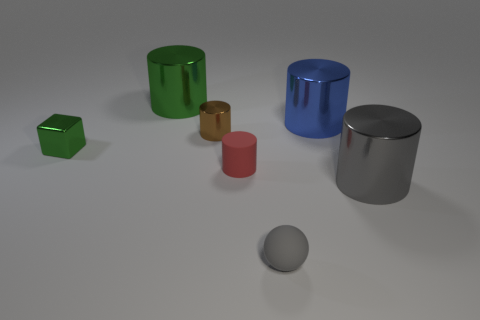Add 1 tiny cyan metallic cylinders. How many objects exist? 8 Subtract all tiny red rubber cylinders. How many cylinders are left? 4 Subtract all brown cylinders. How many cylinders are left? 4 Subtract 4 cylinders. How many cylinders are left? 1 Add 5 rubber things. How many rubber things exist? 7 Subtract 0 red balls. How many objects are left? 7 Subtract all cylinders. How many objects are left? 2 Subtract all gray cylinders. Subtract all yellow blocks. How many cylinders are left? 4 Subtract all green balls. How many cyan cubes are left? 0 Subtract all brown metal cylinders. Subtract all gray cylinders. How many objects are left? 5 